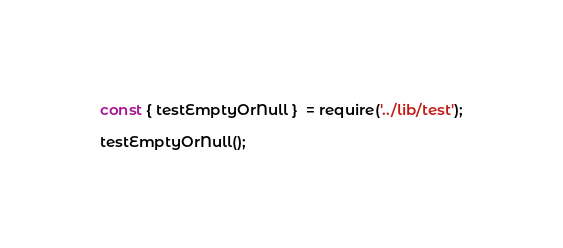Convert code to text. <code><loc_0><loc_0><loc_500><loc_500><_JavaScript_>const { testEmptyOrNull }  = require('../lib/test');

testEmptyOrNull();</code> 